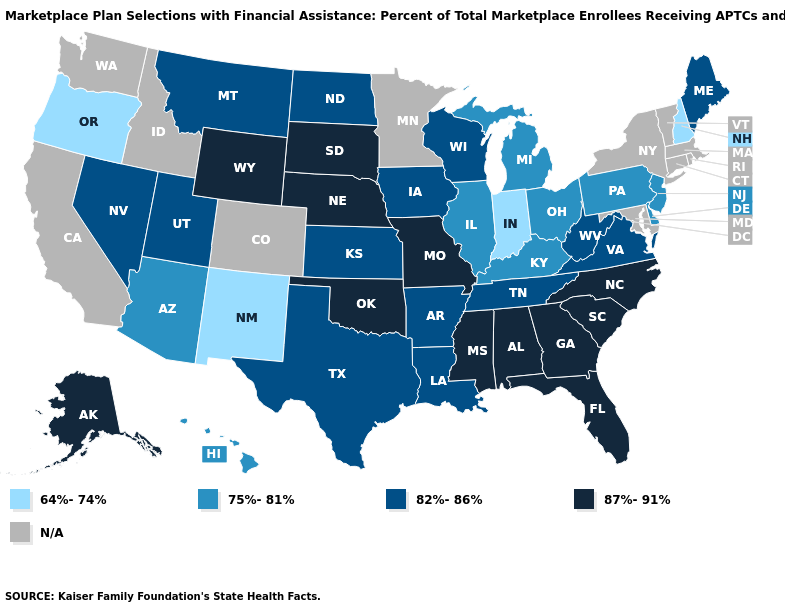Among the states that border Nevada , does Utah have the lowest value?
Write a very short answer. No. Which states hav the highest value in the South?
Quick response, please. Alabama, Florida, Georgia, Mississippi, North Carolina, Oklahoma, South Carolina. What is the value of Michigan?
Concise answer only. 75%-81%. What is the value of Vermont?
Short answer required. N/A. Which states have the lowest value in the USA?
Short answer required. Indiana, New Hampshire, New Mexico, Oregon. Does Indiana have the lowest value in the MidWest?
Short answer required. Yes. Name the states that have a value in the range 64%-74%?
Quick response, please. Indiana, New Hampshire, New Mexico, Oregon. What is the value of Delaware?
Write a very short answer. 75%-81%. How many symbols are there in the legend?
Concise answer only. 5. Among the states that border Oklahoma , which have the highest value?
Be succinct. Missouri. What is the value of Missouri?
Be succinct. 87%-91%. What is the highest value in states that border Nevada?
Write a very short answer. 82%-86%. Name the states that have a value in the range 87%-91%?
Short answer required. Alabama, Alaska, Florida, Georgia, Mississippi, Missouri, Nebraska, North Carolina, Oklahoma, South Carolina, South Dakota, Wyoming. 